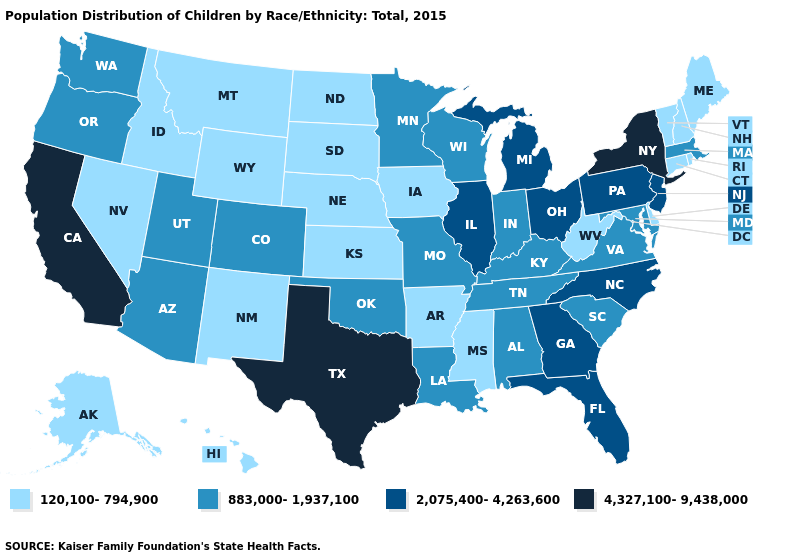What is the lowest value in the South?
Write a very short answer. 120,100-794,900. Name the states that have a value in the range 4,327,100-9,438,000?
Short answer required. California, New York, Texas. Which states have the highest value in the USA?
Quick response, please. California, New York, Texas. Does Minnesota have the lowest value in the USA?
Keep it brief. No. Among the states that border Washington , does Oregon have the lowest value?
Concise answer only. No. What is the value of North Dakota?
Concise answer only. 120,100-794,900. Does Mississippi have the highest value in the USA?
Write a very short answer. No. What is the lowest value in the MidWest?
Write a very short answer. 120,100-794,900. What is the value of Mississippi?
Write a very short answer. 120,100-794,900. Among the states that border Vermont , which have the highest value?
Short answer required. New York. Does Pennsylvania have the lowest value in the Northeast?
Keep it brief. No. What is the value of Mississippi?
Short answer required. 120,100-794,900. What is the highest value in states that border New Hampshire?
Give a very brief answer. 883,000-1,937,100. Which states have the lowest value in the MidWest?
Be succinct. Iowa, Kansas, Nebraska, North Dakota, South Dakota. Among the states that border Vermont , does New York have the lowest value?
Concise answer only. No. 